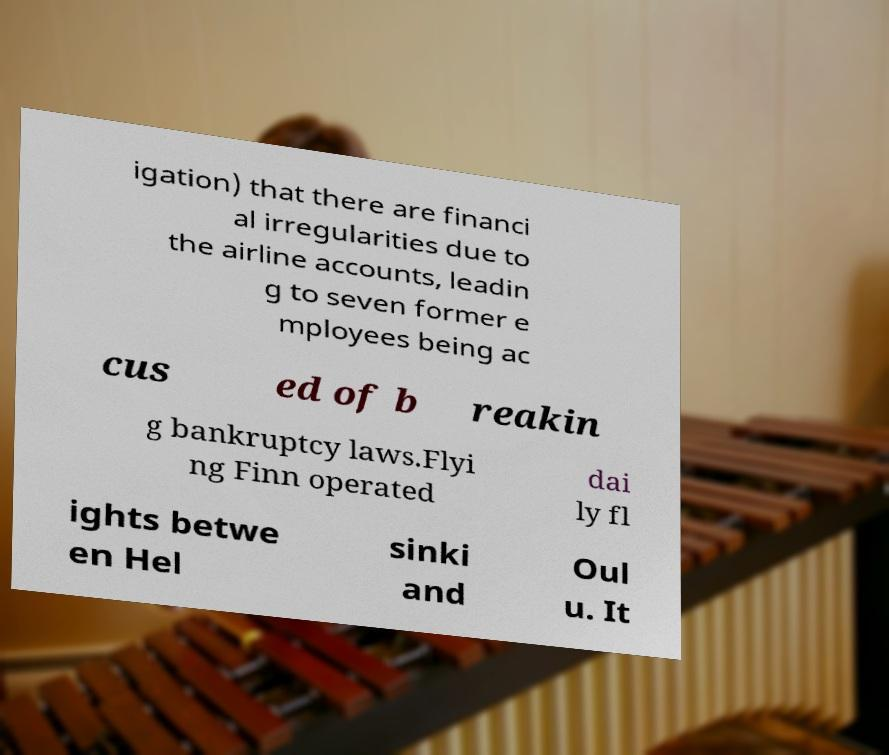Can you read and provide the text displayed in the image?This photo seems to have some interesting text. Can you extract and type it out for me? igation) that there are financi al irregularities due to the airline accounts, leadin g to seven former e mployees being ac cus ed of b reakin g bankruptcy laws.Flyi ng Finn operated dai ly fl ights betwe en Hel sinki and Oul u. It 